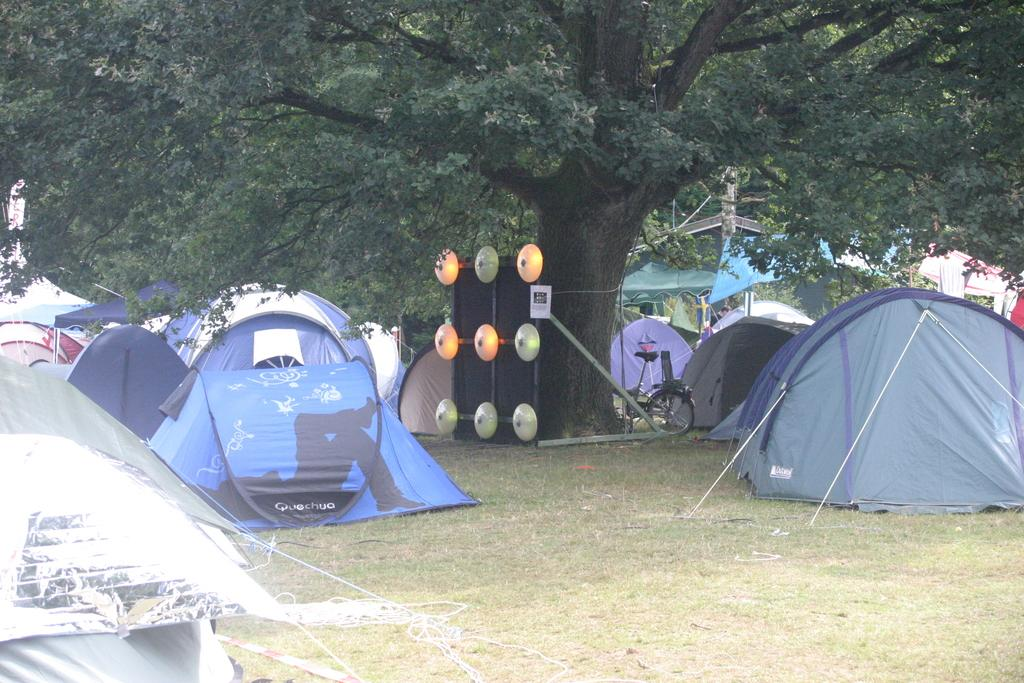What type of temporary shelters can be seen in the image? There are tents in the image. What mode of transportation is present in the image? There is a bicycle in the image. Can you describe any other objects in the image? There are some objects in the image, but their specific nature is not mentioned in the facts. What can be seen in the background of the image? There are trees in the background of the image. What type of flag is being waved by the passenger on the bicycle in the image? There is no flag or passenger on the bicycle in the image, as the facts do not mention them. 